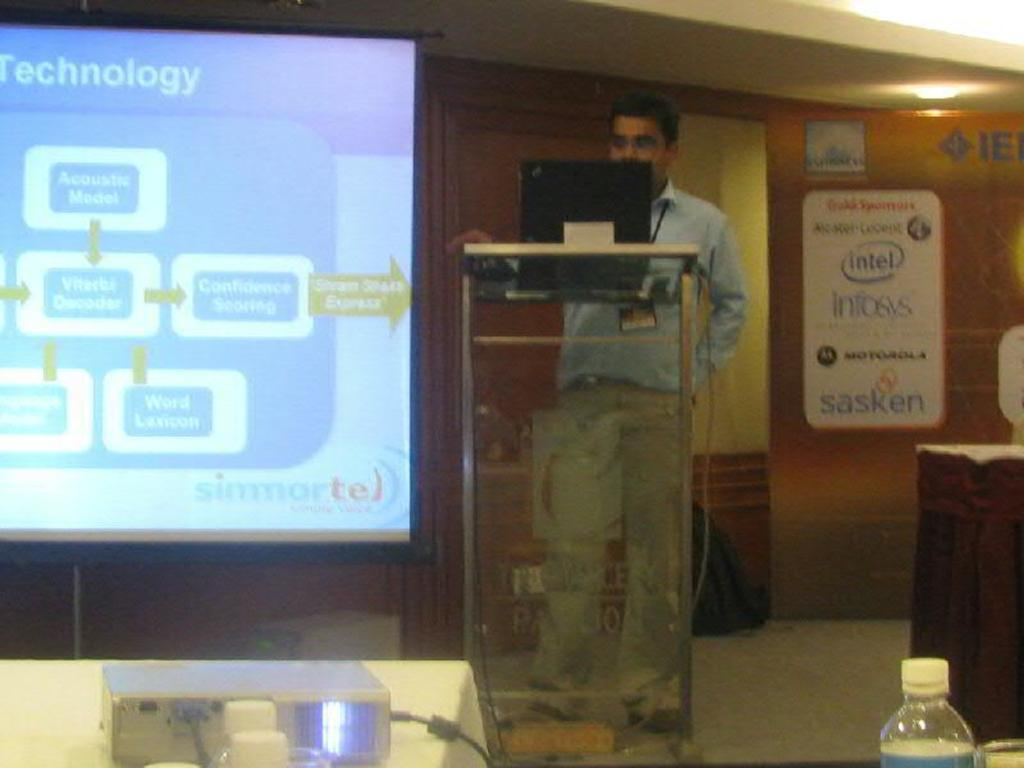<image>
Share a concise interpretation of the image provided. a man standing with a lap top with a screen next to him saying Technology, and a sign on the other side with intel, infosys, Motorola, etc. 